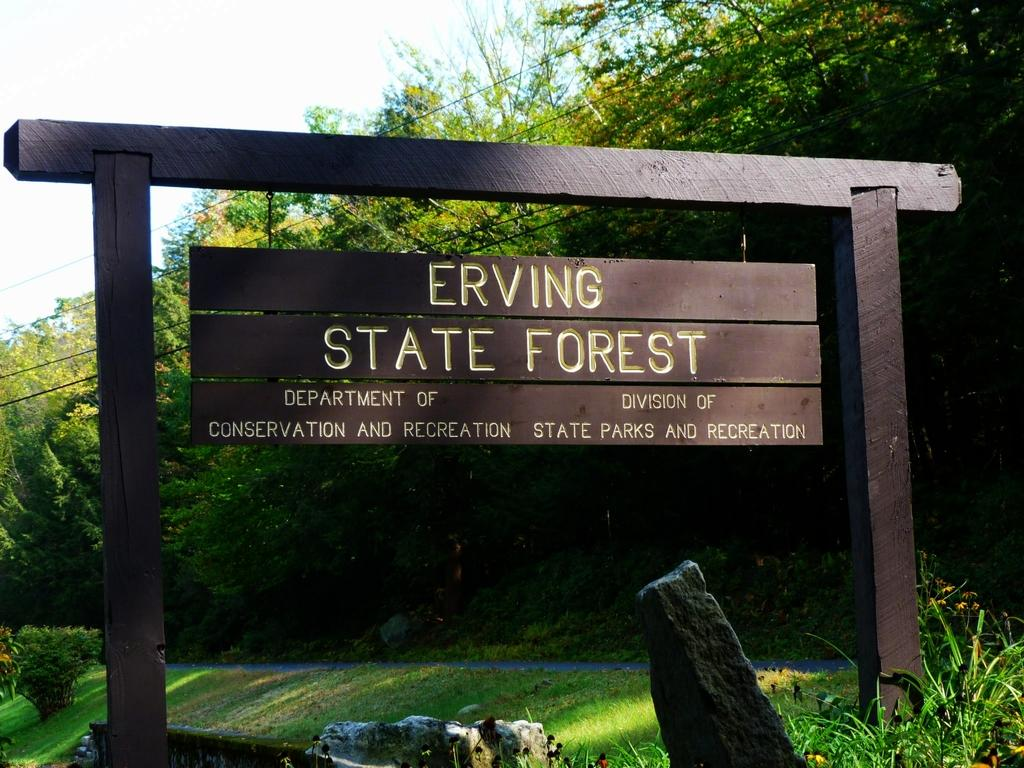What is the main object in the image? There is a board in the image. What type of vegetation can be seen in the image? There are plants and trees in the image. What else is present in the image besides the board and vegetation? There are cables in the image. What can be seen in the background of the image? The sky is visible in the background of the image. How many legs does the mint plant have in the image? There is no mint plant present in the image, and therefore no legs can be counted. 